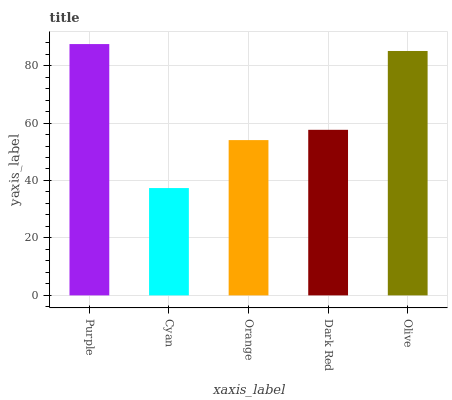Is Cyan the minimum?
Answer yes or no. Yes. Is Purple the maximum?
Answer yes or no. Yes. Is Orange the minimum?
Answer yes or no. No. Is Orange the maximum?
Answer yes or no. No. Is Orange greater than Cyan?
Answer yes or no. Yes. Is Cyan less than Orange?
Answer yes or no. Yes. Is Cyan greater than Orange?
Answer yes or no. No. Is Orange less than Cyan?
Answer yes or no. No. Is Dark Red the high median?
Answer yes or no. Yes. Is Dark Red the low median?
Answer yes or no. Yes. Is Orange the high median?
Answer yes or no. No. Is Purple the low median?
Answer yes or no. No. 